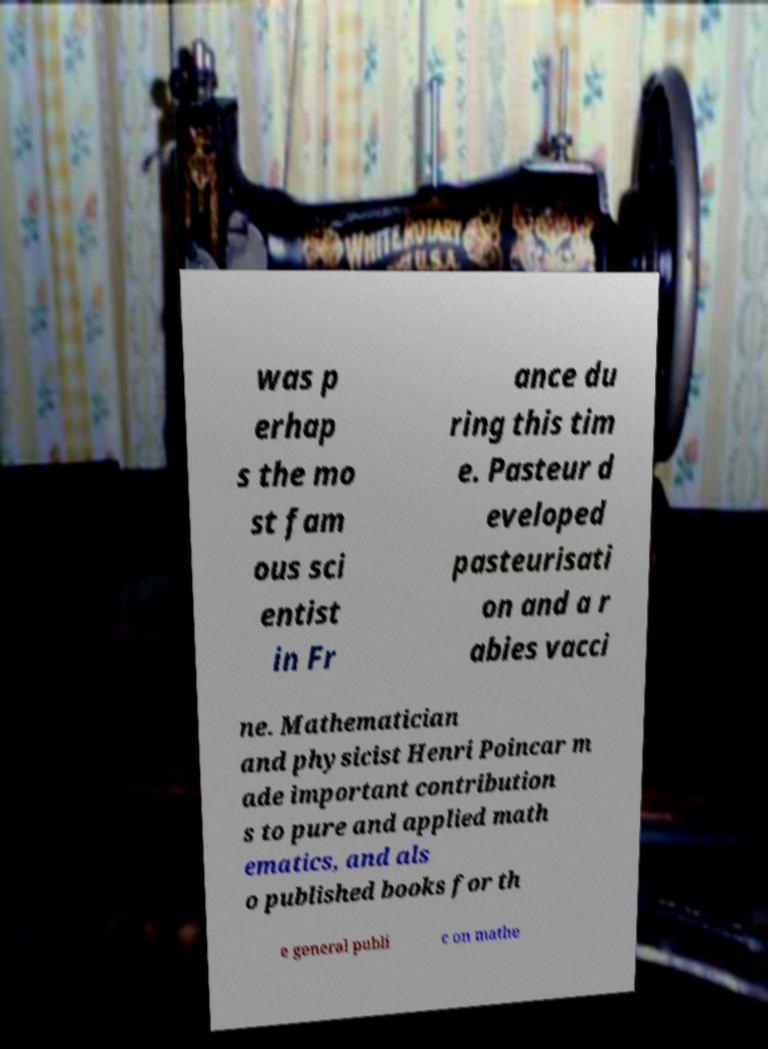What messages or text are displayed in this image? I need them in a readable, typed format. was p erhap s the mo st fam ous sci entist in Fr ance du ring this tim e. Pasteur d eveloped pasteurisati on and a r abies vacci ne. Mathematician and physicist Henri Poincar m ade important contribution s to pure and applied math ematics, and als o published books for th e general publi c on mathe 